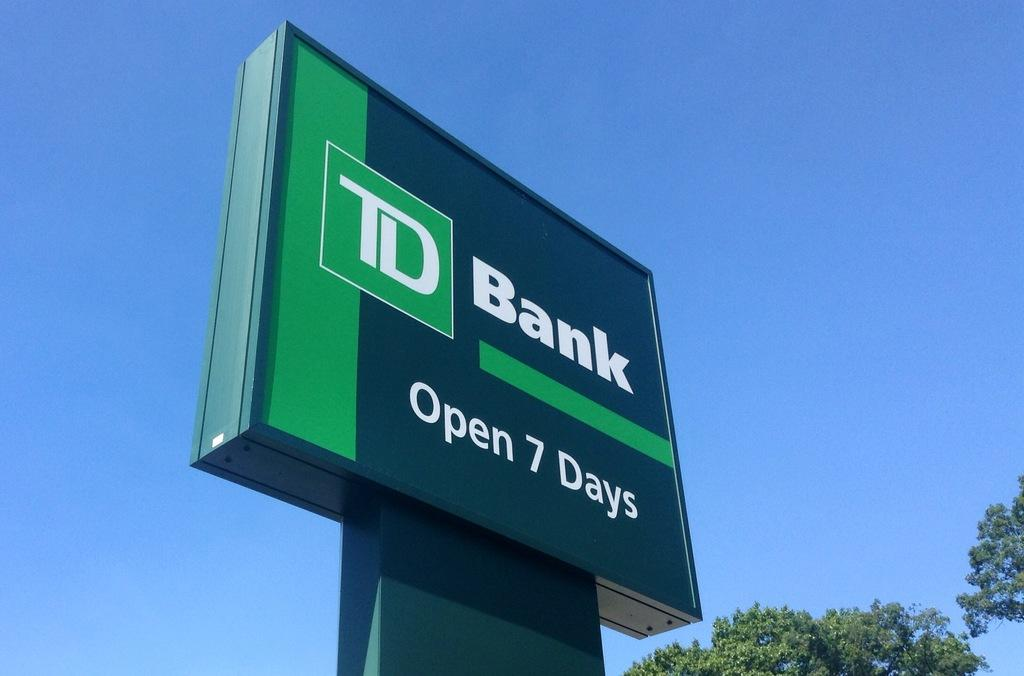<image>
Create a compact narrative representing the image presented. A sign for TD Bank that says Open 7 days. 